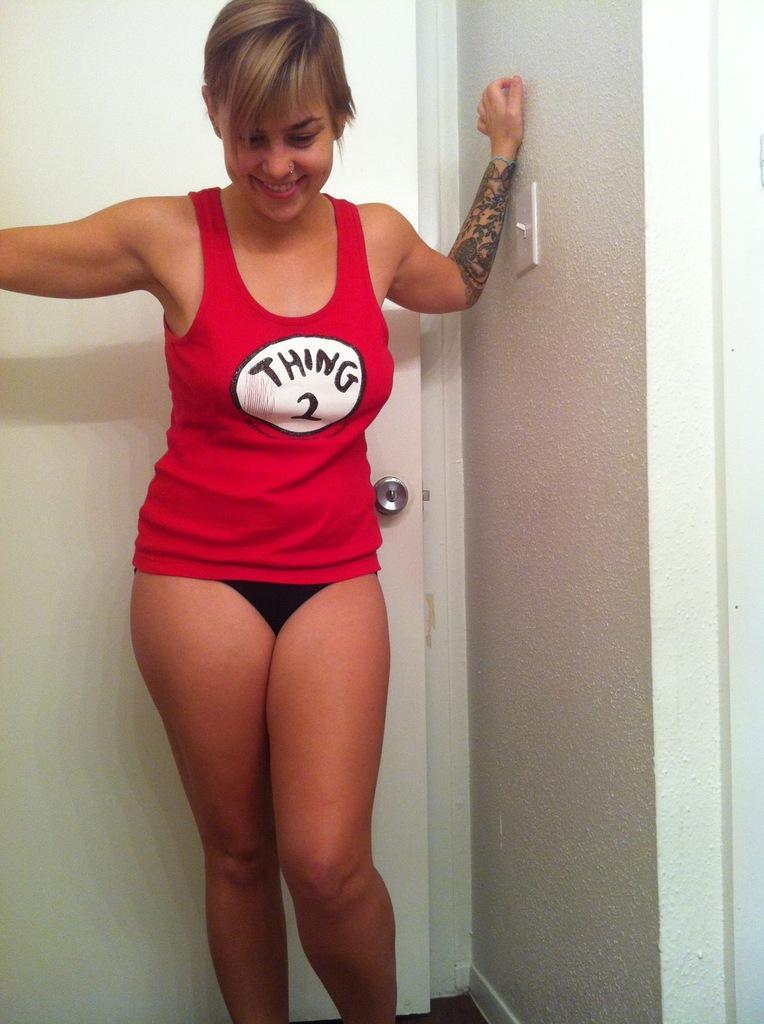Describe this image in one or two sentences. In this picture there is a woman who is wearing t-shirt and short. She is standing near to the door. On the right I can see the wall. 